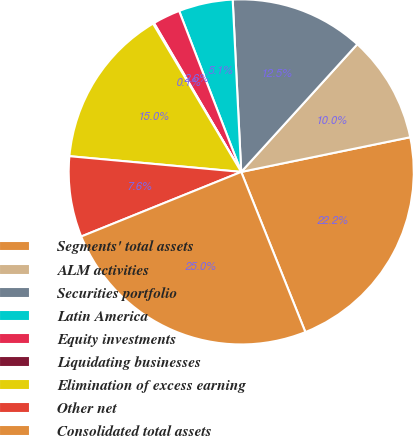<chart> <loc_0><loc_0><loc_500><loc_500><pie_chart><fcel>Segments' total assets<fcel>ALM activities<fcel>Securities portfolio<fcel>Latin America<fcel>Equity investments<fcel>Liquidating businesses<fcel>Elimination of excess earning<fcel>Other net<fcel>Consolidated total assets<nl><fcel>22.16%<fcel>10.04%<fcel>12.53%<fcel>5.07%<fcel>2.58%<fcel>0.1%<fcel>15.01%<fcel>7.56%<fcel>24.96%<nl></chart> 